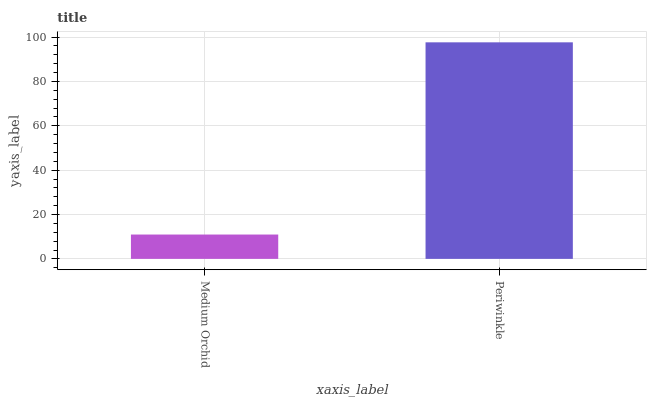Is Medium Orchid the minimum?
Answer yes or no. Yes. Is Periwinkle the maximum?
Answer yes or no. Yes. Is Periwinkle the minimum?
Answer yes or no. No. Is Periwinkle greater than Medium Orchid?
Answer yes or no. Yes. Is Medium Orchid less than Periwinkle?
Answer yes or no. Yes. Is Medium Orchid greater than Periwinkle?
Answer yes or no. No. Is Periwinkle less than Medium Orchid?
Answer yes or no. No. Is Periwinkle the high median?
Answer yes or no. Yes. Is Medium Orchid the low median?
Answer yes or no. Yes. Is Medium Orchid the high median?
Answer yes or no. No. Is Periwinkle the low median?
Answer yes or no. No. 